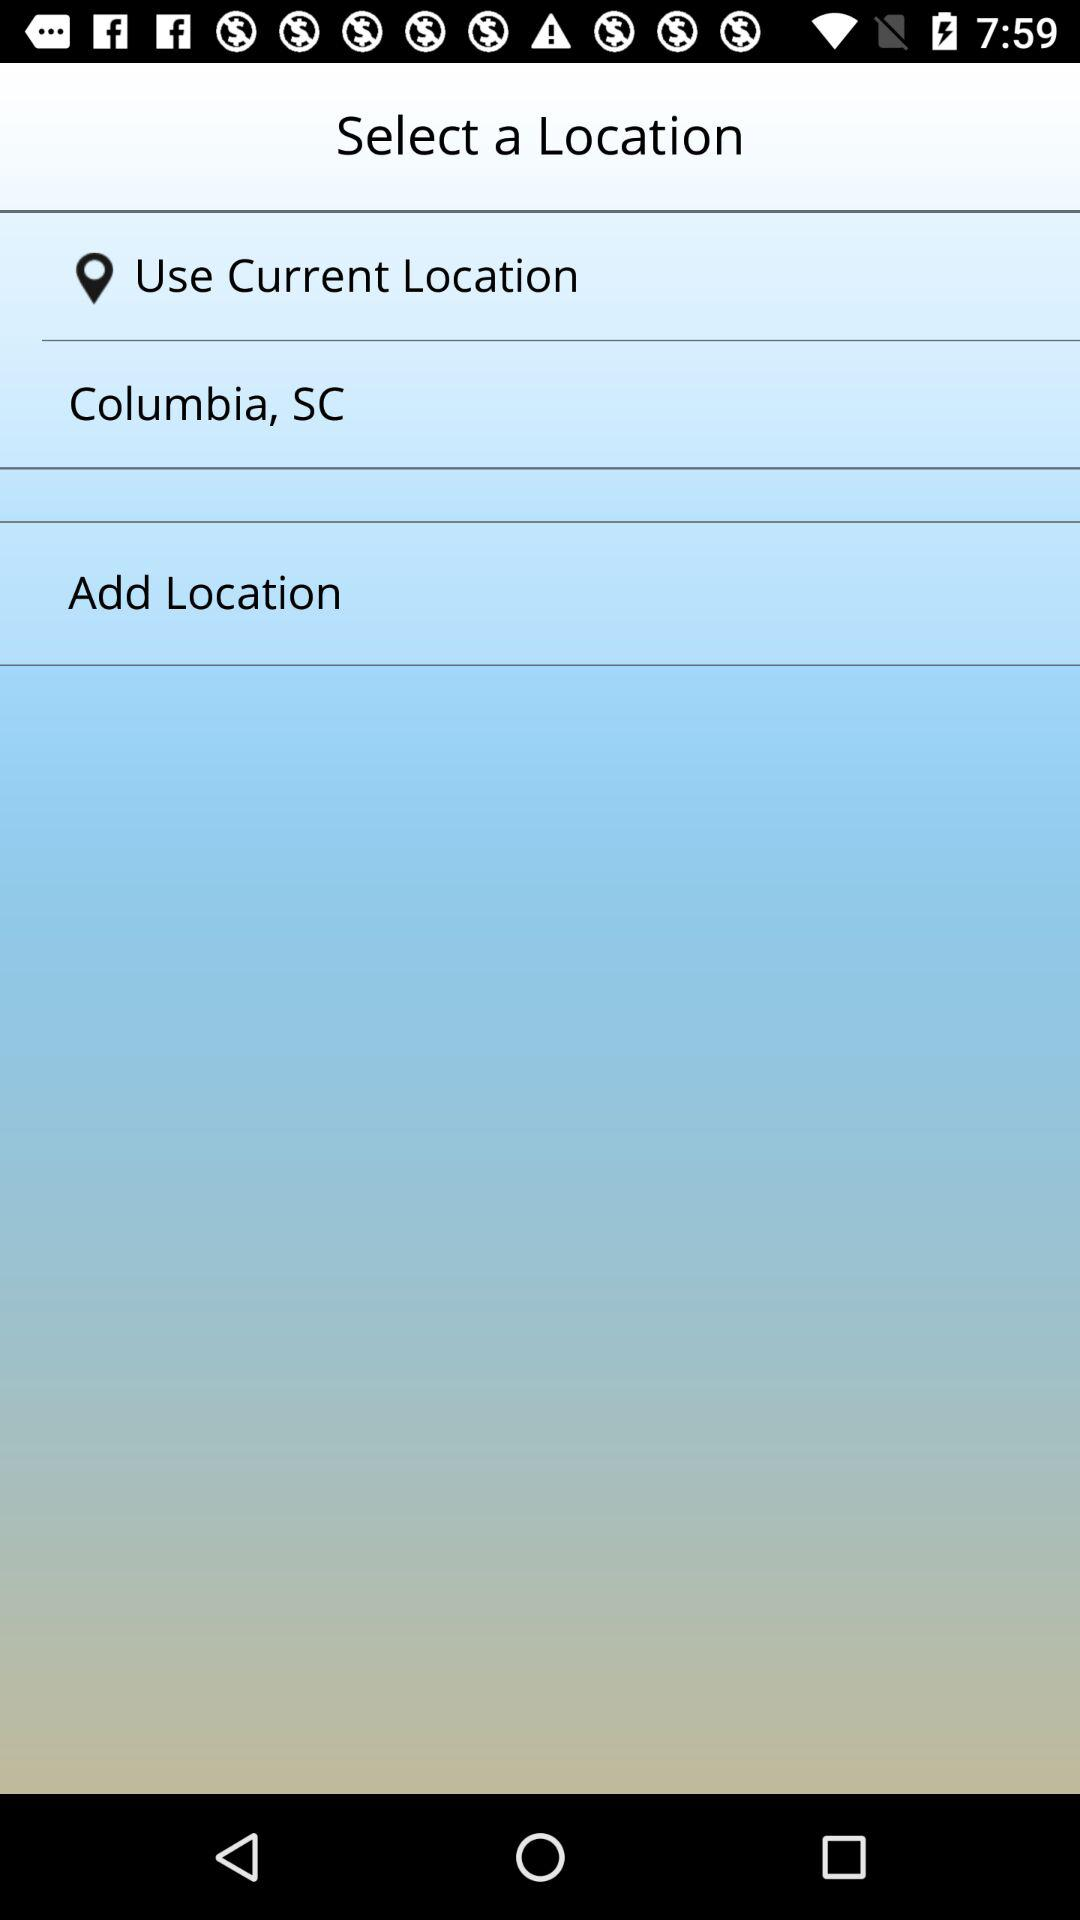How many locations can be added in total?
When the provided information is insufficient, respond with <no answer>. <no answer> 